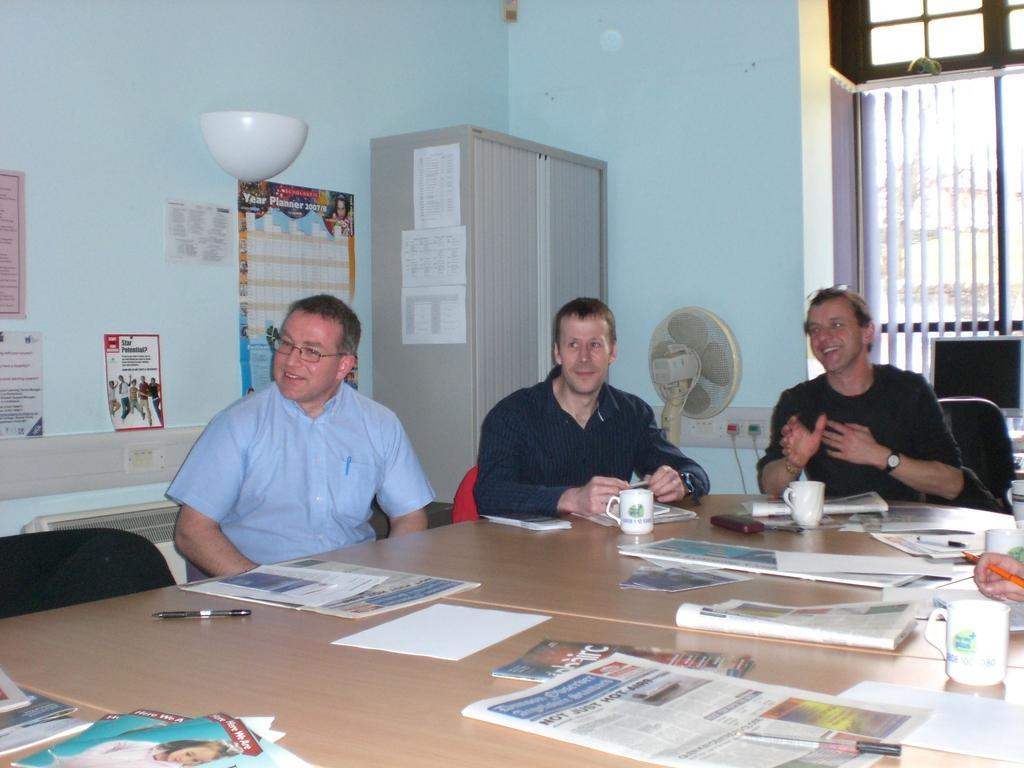In one or two sentences, can you explain what this image depicts? In this image we can see three persons sitting on the chairs in front of the table and smiling and on the table we can see the papers, cups books, and also pens. In the background there is a table fan, monitor, posters with text attached to the wall. We can also see the almirah and the window. 